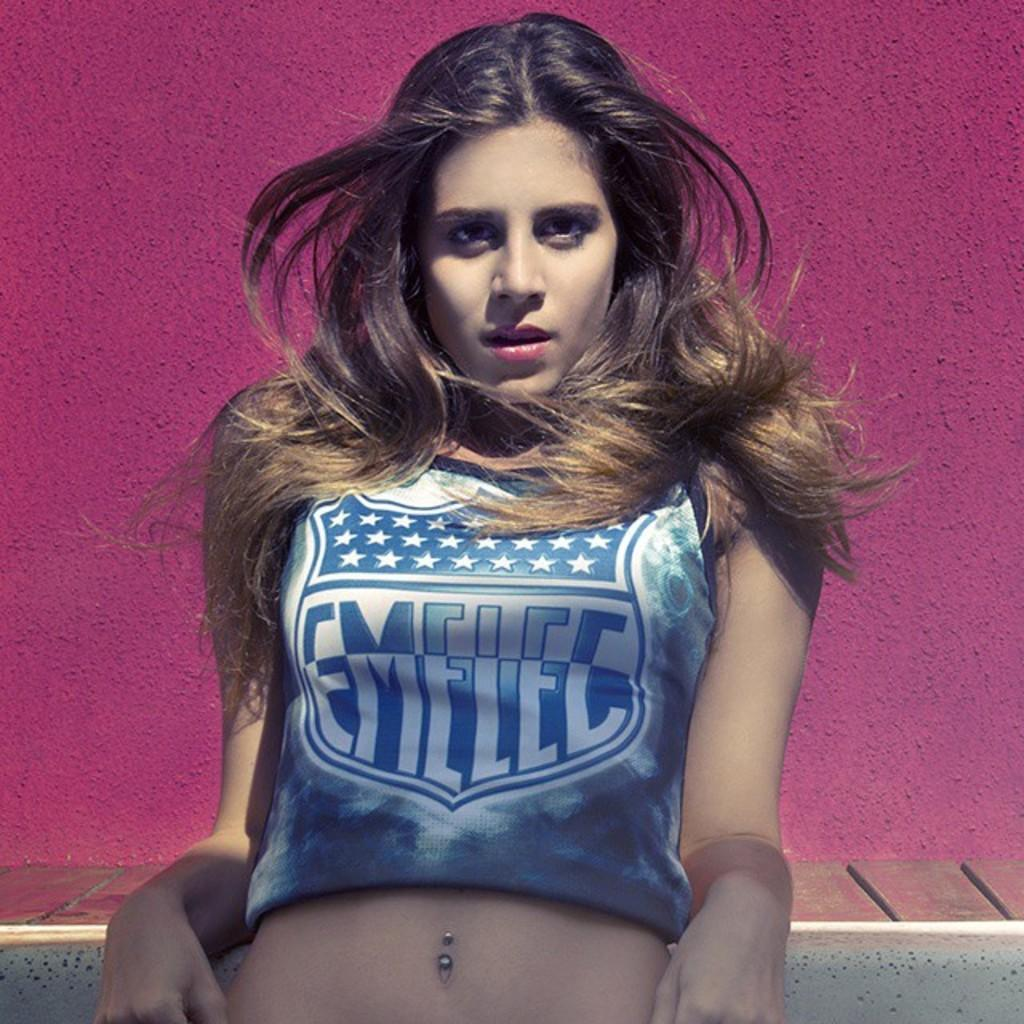<image>
Relay a brief, clear account of the picture shown. A women with long dark hair posing with a crop shirt with the logo Emelec along with a star pattern on the front. 